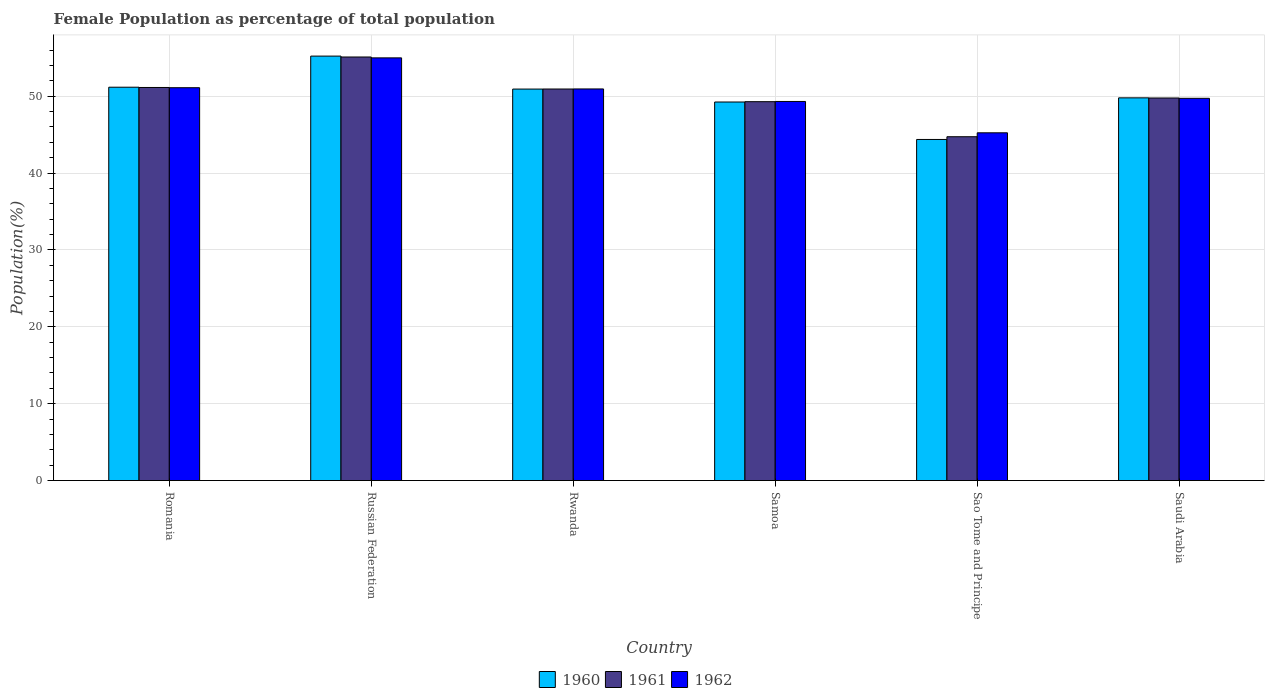Are the number of bars per tick equal to the number of legend labels?
Provide a succinct answer. Yes. Are the number of bars on each tick of the X-axis equal?
Your answer should be compact. Yes. How many bars are there on the 5th tick from the right?
Your response must be concise. 3. What is the label of the 5th group of bars from the left?
Ensure brevity in your answer.  Sao Tome and Principe. What is the female population in in 1960 in Russian Federation?
Your answer should be very brief. 55.21. Across all countries, what is the maximum female population in in 1962?
Provide a succinct answer. 54.98. Across all countries, what is the minimum female population in in 1962?
Your answer should be compact. 45.24. In which country was the female population in in 1962 maximum?
Give a very brief answer. Russian Federation. In which country was the female population in in 1962 minimum?
Your response must be concise. Sao Tome and Principe. What is the total female population in in 1960 in the graph?
Offer a terse response. 300.69. What is the difference between the female population in in 1961 in Russian Federation and that in Sao Tome and Principe?
Give a very brief answer. 10.37. What is the difference between the female population in in 1961 in Saudi Arabia and the female population in in 1962 in Russian Federation?
Provide a succinct answer. -5.22. What is the average female population in in 1961 per country?
Make the answer very short. 50.16. What is the difference between the female population in of/in 1962 and female population in of/in 1960 in Samoa?
Make the answer very short. 0.07. What is the ratio of the female population in in 1961 in Rwanda to that in Saudi Arabia?
Ensure brevity in your answer.  1.02. What is the difference between the highest and the second highest female population in in 1960?
Provide a succinct answer. -0.24. What is the difference between the highest and the lowest female population in in 1962?
Offer a very short reply. 9.75. What does the 1st bar from the left in Samoa represents?
Your answer should be compact. 1960. What does the 2nd bar from the right in Russian Federation represents?
Provide a short and direct response. 1961. How many bars are there?
Your answer should be compact. 18. Are all the bars in the graph horizontal?
Provide a short and direct response. No. How many countries are there in the graph?
Ensure brevity in your answer.  6. What is the title of the graph?
Your response must be concise. Female Population as percentage of total population. What is the label or title of the Y-axis?
Provide a succinct answer. Population(%). What is the Population(%) of 1960 in Romania?
Provide a succinct answer. 51.17. What is the Population(%) of 1961 in Romania?
Make the answer very short. 51.13. What is the Population(%) of 1962 in Romania?
Keep it short and to the point. 51.1. What is the Population(%) of 1960 in Russian Federation?
Offer a very short reply. 55.21. What is the Population(%) in 1961 in Russian Federation?
Your response must be concise. 55.1. What is the Population(%) in 1962 in Russian Federation?
Offer a terse response. 54.98. What is the Population(%) of 1960 in Rwanda?
Provide a short and direct response. 50.92. What is the Population(%) in 1961 in Rwanda?
Your answer should be compact. 50.93. What is the Population(%) in 1962 in Rwanda?
Give a very brief answer. 50.94. What is the Population(%) in 1960 in Samoa?
Give a very brief answer. 49.24. What is the Population(%) in 1961 in Samoa?
Your answer should be compact. 49.28. What is the Population(%) in 1962 in Samoa?
Offer a terse response. 49.31. What is the Population(%) in 1960 in Sao Tome and Principe?
Make the answer very short. 44.37. What is the Population(%) of 1961 in Sao Tome and Principe?
Make the answer very short. 44.73. What is the Population(%) in 1962 in Sao Tome and Principe?
Give a very brief answer. 45.24. What is the Population(%) of 1960 in Saudi Arabia?
Your response must be concise. 49.78. What is the Population(%) of 1961 in Saudi Arabia?
Offer a terse response. 49.76. What is the Population(%) of 1962 in Saudi Arabia?
Make the answer very short. 49.72. Across all countries, what is the maximum Population(%) in 1960?
Your answer should be very brief. 55.21. Across all countries, what is the maximum Population(%) of 1961?
Offer a terse response. 55.1. Across all countries, what is the maximum Population(%) in 1962?
Your response must be concise. 54.98. Across all countries, what is the minimum Population(%) of 1960?
Make the answer very short. 44.37. Across all countries, what is the minimum Population(%) of 1961?
Your answer should be compact. 44.73. Across all countries, what is the minimum Population(%) in 1962?
Your response must be concise. 45.24. What is the total Population(%) in 1960 in the graph?
Offer a terse response. 300.69. What is the total Population(%) of 1961 in the graph?
Give a very brief answer. 300.93. What is the total Population(%) in 1962 in the graph?
Your response must be concise. 301.29. What is the difference between the Population(%) of 1960 in Romania and that in Russian Federation?
Your answer should be very brief. -4.05. What is the difference between the Population(%) in 1961 in Romania and that in Russian Federation?
Make the answer very short. -3.96. What is the difference between the Population(%) in 1962 in Romania and that in Russian Federation?
Make the answer very short. -3.88. What is the difference between the Population(%) of 1960 in Romania and that in Rwanda?
Give a very brief answer. 0.24. What is the difference between the Population(%) in 1961 in Romania and that in Rwanda?
Offer a very short reply. 0.2. What is the difference between the Population(%) of 1962 in Romania and that in Rwanda?
Your answer should be very brief. 0.16. What is the difference between the Population(%) in 1960 in Romania and that in Samoa?
Provide a succinct answer. 1.92. What is the difference between the Population(%) in 1961 in Romania and that in Samoa?
Give a very brief answer. 1.85. What is the difference between the Population(%) in 1962 in Romania and that in Samoa?
Your answer should be very brief. 1.79. What is the difference between the Population(%) of 1960 in Romania and that in Sao Tome and Principe?
Provide a succinct answer. 6.8. What is the difference between the Population(%) in 1961 in Romania and that in Sao Tome and Principe?
Offer a very short reply. 6.41. What is the difference between the Population(%) of 1962 in Romania and that in Sao Tome and Principe?
Provide a succinct answer. 5.87. What is the difference between the Population(%) of 1960 in Romania and that in Saudi Arabia?
Give a very brief answer. 1.38. What is the difference between the Population(%) in 1961 in Romania and that in Saudi Arabia?
Offer a terse response. 1.37. What is the difference between the Population(%) of 1962 in Romania and that in Saudi Arabia?
Your response must be concise. 1.38. What is the difference between the Population(%) in 1960 in Russian Federation and that in Rwanda?
Keep it short and to the point. 4.29. What is the difference between the Population(%) in 1961 in Russian Federation and that in Rwanda?
Your answer should be very brief. 4.16. What is the difference between the Population(%) of 1962 in Russian Federation and that in Rwanda?
Ensure brevity in your answer.  4.04. What is the difference between the Population(%) of 1960 in Russian Federation and that in Samoa?
Ensure brevity in your answer.  5.97. What is the difference between the Population(%) in 1961 in Russian Federation and that in Samoa?
Your answer should be compact. 5.81. What is the difference between the Population(%) of 1962 in Russian Federation and that in Samoa?
Your response must be concise. 5.67. What is the difference between the Population(%) of 1960 in Russian Federation and that in Sao Tome and Principe?
Ensure brevity in your answer.  10.84. What is the difference between the Population(%) of 1961 in Russian Federation and that in Sao Tome and Principe?
Provide a short and direct response. 10.37. What is the difference between the Population(%) of 1962 in Russian Federation and that in Sao Tome and Principe?
Offer a very short reply. 9.75. What is the difference between the Population(%) in 1960 in Russian Federation and that in Saudi Arabia?
Make the answer very short. 5.43. What is the difference between the Population(%) of 1961 in Russian Federation and that in Saudi Arabia?
Your answer should be very brief. 5.33. What is the difference between the Population(%) in 1962 in Russian Federation and that in Saudi Arabia?
Ensure brevity in your answer.  5.26. What is the difference between the Population(%) of 1960 in Rwanda and that in Samoa?
Offer a very short reply. 1.68. What is the difference between the Population(%) in 1961 in Rwanda and that in Samoa?
Offer a terse response. 1.65. What is the difference between the Population(%) in 1962 in Rwanda and that in Samoa?
Your answer should be very brief. 1.63. What is the difference between the Population(%) of 1960 in Rwanda and that in Sao Tome and Principe?
Ensure brevity in your answer.  6.55. What is the difference between the Population(%) of 1961 in Rwanda and that in Sao Tome and Principe?
Offer a very short reply. 6.21. What is the difference between the Population(%) in 1962 in Rwanda and that in Sao Tome and Principe?
Provide a short and direct response. 5.7. What is the difference between the Population(%) of 1960 in Rwanda and that in Saudi Arabia?
Give a very brief answer. 1.14. What is the difference between the Population(%) of 1961 in Rwanda and that in Saudi Arabia?
Ensure brevity in your answer.  1.17. What is the difference between the Population(%) of 1962 in Rwanda and that in Saudi Arabia?
Make the answer very short. 1.22. What is the difference between the Population(%) of 1960 in Samoa and that in Sao Tome and Principe?
Your answer should be compact. 4.87. What is the difference between the Population(%) in 1961 in Samoa and that in Sao Tome and Principe?
Offer a very short reply. 4.56. What is the difference between the Population(%) of 1962 in Samoa and that in Sao Tome and Principe?
Provide a succinct answer. 4.08. What is the difference between the Population(%) in 1960 in Samoa and that in Saudi Arabia?
Your answer should be compact. -0.54. What is the difference between the Population(%) in 1961 in Samoa and that in Saudi Arabia?
Your answer should be very brief. -0.48. What is the difference between the Population(%) of 1962 in Samoa and that in Saudi Arabia?
Your answer should be compact. -0.41. What is the difference between the Population(%) in 1960 in Sao Tome and Principe and that in Saudi Arabia?
Provide a succinct answer. -5.41. What is the difference between the Population(%) of 1961 in Sao Tome and Principe and that in Saudi Arabia?
Offer a very short reply. -5.04. What is the difference between the Population(%) of 1962 in Sao Tome and Principe and that in Saudi Arabia?
Offer a terse response. -4.48. What is the difference between the Population(%) of 1960 in Romania and the Population(%) of 1961 in Russian Federation?
Make the answer very short. -3.93. What is the difference between the Population(%) of 1960 in Romania and the Population(%) of 1962 in Russian Federation?
Provide a succinct answer. -3.82. What is the difference between the Population(%) of 1961 in Romania and the Population(%) of 1962 in Russian Federation?
Your answer should be compact. -3.85. What is the difference between the Population(%) of 1960 in Romania and the Population(%) of 1961 in Rwanda?
Keep it short and to the point. 0.23. What is the difference between the Population(%) in 1960 in Romania and the Population(%) in 1962 in Rwanda?
Your response must be concise. 0.23. What is the difference between the Population(%) of 1961 in Romania and the Population(%) of 1962 in Rwanda?
Your answer should be compact. 0.19. What is the difference between the Population(%) in 1960 in Romania and the Population(%) in 1961 in Samoa?
Your response must be concise. 1.88. What is the difference between the Population(%) of 1960 in Romania and the Population(%) of 1962 in Samoa?
Give a very brief answer. 1.85. What is the difference between the Population(%) of 1961 in Romania and the Population(%) of 1962 in Samoa?
Give a very brief answer. 1.82. What is the difference between the Population(%) of 1960 in Romania and the Population(%) of 1961 in Sao Tome and Principe?
Offer a terse response. 6.44. What is the difference between the Population(%) of 1960 in Romania and the Population(%) of 1962 in Sao Tome and Principe?
Offer a terse response. 5.93. What is the difference between the Population(%) of 1961 in Romania and the Population(%) of 1962 in Sao Tome and Principe?
Your response must be concise. 5.9. What is the difference between the Population(%) in 1960 in Romania and the Population(%) in 1961 in Saudi Arabia?
Your response must be concise. 1.4. What is the difference between the Population(%) in 1960 in Romania and the Population(%) in 1962 in Saudi Arabia?
Your answer should be compact. 1.45. What is the difference between the Population(%) in 1961 in Romania and the Population(%) in 1962 in Saudi Arabia?
Your answer should be very brief. 1.41. What is the difference between the Population(%) of 1960 in Russian Federation and the Population(%) of 1961 in Rwanda?
Your answer should be very brief. 4.28. What is the difference between the Population(%) of 1960 in Russian Federation and the Population(%) of 1962 in Rwanda?
Your answer should be very brief. 4.27. What is the difference between the Population(%) of 1961 in Russian Federation and the Population(%) of 1962 in Rwanda?
Provide a succinct answer. 4.16. What is the difference between the Population(%) in 1960 in Russian Federation and the Population(%) in 1961 in Samoa?
Offer a terse response. 5.93. What is the difference between the Population(%) of 1960 in Russian Federation and the Population(%) of 1962 in Samoa?
Your response must be concise. 5.9. What is the difference between the Population(%) of 1961 in Russian Federation and the Population(%) of 1962 in Samoa?
Give a very brief answer. 5.78. What is the difference between the Population(%) of 1960 in Russian Federation and the Population(%) of 1961 in Sao Tome and Principe?
Ensure brevity in your answer.  10.49. What is the difference between the Population(%) in 1960 in Russian Federation and the Population(%) in 1962 in Sao Tome and Principe?
Your answer should be very brief. 9.98. What is the difference between the Population(%) of 1961 in Russian Federation and the Population(%) of 1962 in Sao Tome and Principe?
Offer a very short reply. 9.86. What is the difference between the Population(%) in 1960 in Russian Federation and the Population(%) in 1961 in Saudi Arabia?
Provide a short and direct response. 5.45. What is the difference between the Population(%) of 1960 in Russian Federation and the Population(%) of 1962 in Saudi Arabia?
Keep it short and to the point. 5.49. What is the difference between the Population(%) of 1961 in Russian Federation and the Population(%) of 1962 in Saudi Arabia?
Give a very brief answer. 5.38. What is the difference between the Population(%) of 1960 in Rwanda and the Population(%) of 1961 in Samoa?
Make the answer very short. 1.64. What is the difference between the Population(%) of 1960 in Rwanda and the Population(%) of 1962 in Samoa?
Offer a terse response. 1.61. What is the difference between the Population(%) of 1961 in Rwanda and the Population(%) of 1962 in Samoa?
Give a very brief answer. 1.62. What is the difference between the Population(%) of 1960 in Rwanda and the Population(%) of 1961 in Sao Tome and Principe?
Ensure brevity in your answer.  6.2. What is the difference between the Population(%) of 1960 in Rwanda and the Population(%) of 1962 in Sao Tome and Principe?
Make the answer very short. 5.69. What is the difference between the Population(%) of 1961 in Rwanda and the Population(%) of 1962 in Sao Tome and Principe?
Your answer should be compact. 5.7. What is the difference between the Population(%) of 1960 in Rwanda and the Population(%) of 1961 in Saudi Arabia?
Provide a succinct answer. 1.16. What is the difference between the Population(%) in 1960 in Rwanda and the Population(%) in 1962 in Saudi Arabia?
Your answer should be very brief. 1.2. What is the difference between the Population(%) of 1961 in Rwanda and the Population(%) of 1962 in Saudi Arabia?
Keep it short and to the point. 1.21. What is the difference between the Population(%) in 1960 in Samoa and the Population(%) in 1961 in Sao Tome and Principe?
Provide a succinct answer. 4.52. What is the difference between the Population(%) of 1960 in Samoa and the Population(%) of 1962 in Sao Tome and Principe?
Offer a terse response. 4.01. What is the difference between the Population(%) in 1961 in Samoa and the Population(%) in 1962 in Sao Tome and Principe?
Provide a succinct answer. 4.05. What is the difference between the Population(%) of 1960 in Samoa and the Population(%) of 1961 in Saudi Arabia?
Your response must be concise. -0.52. What is the difference between the Population(%) in 1960 in Samoa and the Population(%) in 1962 in Saudi Arabia?
Ensure brevity in your answer.  -0.48. What is the difference between the Population(%) of 1961 in Samoa and the Population(%) of 1962 in Saudi Arabia?
Keep it short and to the point. -0.44. What is the difference between the Population(%) in 1960 in Sao Tome and Principe and the Population(%) in 1961 in Saudi Arabia?
Your answer should be very brief. -5.39. What is the difference between the Population(%) of 1960 in Sao Tome and Principe and the Population(%) of 1962 in Saudi Arabia?
Offer a terse response. -5.35. What is the difference between the Population(%) of 1961 in Sao Tome and Principe and the Population(%) of 1962 in Saudi Arabia?
Your response must be concise. -4.99. What is the average Population(%) of 1960 per country?
Provide a succinct answer. 50.12. What is the average Population(%) of 1961 per country?
Provide a succinct answer. 50.16. What is the average Population(%) of 1962 per country?
Ensure brevity in your answer.  50.22. What is the difference between the Population(%) of 1960 and Population(%) of 1961 in Romania?
Your answer should be very brief. 0.03. What is the difference between the Population(%) in 1960 and Population(%) in 1962 in Romania?
Make the answer very short. 0.06. What is the difference between the Population(%) of 1961 and Population(%) of 1962 in Romania?
Your response must be concise. 0.03. What is the difference between the Population(%) of 1960 and Population(%) of 1961 in Russian Federation?
Offer a very short reply. 0.12. What is the difference between the Population(%) of 1960 and Population(%) of 1962 in Russian Federation?
Your answer should be compact. 0.23. What is the difference between the Population(%) in 1961 and Population(%) in 1962 in Russian Federation?
Offer a terse response. 0.11. What is the difference between the Population(%) in 1960 and Population(%) in 1961 in Rwanda?
Offer a terse response. -0.01. What is the difference between the Population(%) in 1960 and Population(%) in 1962 in Rwanda?
Make the answer very short. -0.02. What is the difference between the Population(%) of 1961 and Population(%) of 1962 in Rwanda?
Offer a very short reply. -0.01. What is the difference between the Population(%) in 1960 and Population(%) in 1961 in Samoa?
Provide a short and direct response. -0.04. What is the difference between the Population(%) in 1960 and Population(%) in 1962 in Samoa?
Offer a terse response. -0.07. What is the difference between the Population(%) of 1961 and Population(%) of 1962 in Samoa?
Your response must be concise. -0.03. What is the difference between the Population(%) of 1960 and Population(%) of 1961 in Sao Tome and Principe?
Your answer should be compact. -0.36. What is the difference between the Population(%) in 1960 and Population(%) in 1962 in Sao Tome and Principe?
Your response must be concise. -0.87. What is the difference between the Population(%) of 1961 and Population(%) of 1962 in Sao Tome and Principe?
Ensure brevity in your answer.  -0.51. What is the difference between the Population(%) in 1960 and Population(%) in 1961 in Saudi Arabia?
Keep it short and to the point. 0.02. What is the difference between the Population(%) of 1960 and Population(%) of 1962 in Saudi Arabia?
Your answer should be very brief. 0.06. What is the difference between the Population(%) of 1961 and Population(%) of 1962 in Saudi Arabia?
Keep it short and to the point. 0.04. What is the ratio of the Population(%) in 1960 in Romania to that in Russian Federation?
Your response must be concise. 0.93. What is the ratio of the Population(%) of 1961 in Romania to that in Russian Federation?
Make the answer very short. 0.93. What is the ratio of the Population(%) of 1962 in Romania to that in Russian Federation?
Offer a very short reply. 0.93. What is the ratio of the Population(%) in 1960 in Romania to that in Samoa?
Make the answer very short. 1.04. What is the ratio of the Population(%) of 1961 in Romania to that in Samoa?
Your answer should be very brief. 1.04. What is the ratio of the Population(%) of 1962 in Romania to that in Samoa?
Keep it short and to the point. 1.04. What is the ratio of the Population(%) in 1960 in Romania to that in Sao Tome and Principe?
Your response must be concise. 1.15. What is the ratio of the Population(%) in 1961 in Romania to that in Sao Tome and Principe?
Offer a terse response. 1.14. What is the ratio of the Population(%) in 1962 in Romania to that in Sao Tome and Principe?
Give a very brief answer. 1.13. What is the ratio of the Population(%) of 1960 in Romania to that in Saudi Arabia?
Provide a short and direct response. 1.03. What is the ratio of the Population(%) of 1961 in Romania to that in Saudi Arabia?
Offer a terse response. 1.03. What is the ratio of the Population(%) in 1962 in Romania to that in Saudi Arabia?
Provide a short and direct response. 1.03. What is the ratio of the Population(%) of 1960 in Russian Federation to that in Rwanda?
Your response must be concise. 1.08. What is the ratio of the Population(%) in 1961 in Russian Federation to that in Rwanda?
Give a very brief answer. 1.08. What is the ratio of the Population(%) of 1962 in Russian Federation to that in Rwanda?
Provide a succinct answer. 1.08. What is the ratio of the Population(%) of 1960 in Russian Federation to that in Samoa?
Offer a terse response. 1.12. What is the ratio of the Population(%) in 1961 in Russian Federation to that in Samoa?
Ensure brevity in your answer.  1.12. What is the ratio of the Population(%) of 1962 in Russian Federation to that in Samoa?
Make the answer very short. 1.11. What is the ratio of the Population(%) of 1960 in Russian Federation to that in Sao Tome and Principe?
Keep it short and to the point. 1.24. What is the ratio of the Population(%) in 1961 in Russian Federation to that in Sao Tome and Principe?
Offer a terse response. 1.23. What is the ratio of the Population(%) of 1962 in Russian Federation to that in Sao Tome and Principe?
Give a very brief answer. 1.22. What is the ratio of the Population(%) of 1960 in Russian Federation to that in Saudi Arabia?
Ensure brevity in your answer.  1.11. What is the ratio of the Population(%) in 1961 in Russian Federation to that in Saudi Arabia?
Provide a short and direct response. 1.11. What is the ratio of the Population(%) in 1962 in Russian Federation to that in Saudi Arabia?
Your answer should be very brief. 1.11. What is the ratio of the Population(%) in 1960 in Rwanda to that in Samoa?
Offer a very short reply. 1.03. What is the ratio of the Population(%) in 1961 in Rwanda to that in Samoa?
Your answer should be very brief. 1.03. What is the ratio of the Population(%) in 1962 in Rwanda to that in Samoa?
Offer a very short reply. 1.03. What is the ratio of the Population(%) in 1960 in Rwanda to that in Sao Tome and Principe?
Provide a short and direct response. 1.15. What is the ratio of the Population(%) of 1961 in Rwanda to that in Sao Tome and Principe?
Your answer should be very brief. 1.14. What is the ratio of the Population(%) of 1962 in Rwanda to that in Sao Tome and Principe?
Your answer should be compact. 1.13. What is the ratio of the Population(%) in 1960 in Rwanda to that in Saudi Arabia?
Ensure brevity in your answer.  1.02. What is the ratio of the Population(%) in 1961 in Rwanda to that in Saudi Arabia?
Provide a short and direct response. 1.02. What is the ratio of the Population(%) in 1962 in Rwanda to that in Saudi Arabia?
Your answer should be very brief. 1.02. What is the ratio of the Population(%) of 1960 in Samoa to that in Sao Tome and Principe?
Offer a very short reply. 1.11. What is the ratio of the Population(%) of 1961 in Samoa to that in Sao Tome and Principe?
Offer a terse response. 1.1. What is the ratio of the Population(%) in 1962 in Samoa to that in Sao Tome and Principe?
Provide a succinct answer. 1.09. What is the ratio of the Population(%) in 1960 in Samoa to that in Saudi Arabia?
Keep it short and to the point. 0.99. What is the ratio of the Population(%) in 1960 in Sao Tome and Principe to that in Saudi Arabia?
Provide a succinct answer. 0.89. What is the ratio of the Population(%) of 1961 in Sao Tome and Principe to that in Saudi Arabia?
Provide a succinct answer. 0.9. What is the ratio of the Population(%) in 1962 in Sao Tome and Principe to that in Saudi Arabia?
Keep it short and to the point. 0.91. What is the difference between the highest and the second highest Population(%) of 1960?
Offer a terse response. 4.05. What is the difference between the highest and the second highest Population(%) in 1961?
Give a very brief answer. 3.96. What is the difference between the highest and the second highest Population(%) in 1962?
Offer a very short reply. 3.88. What is the difference between the highest and the lowest Population(%) of 1960?
Your answer should be very brief. 10.84. What is the difference between the highest and the lowest Population(%) in 1961?
Offer a terse response. 10.37. What is the difference between the highest and the lowest Population(%) in 1962?
Ensure brevity in your answer.  9.75. 